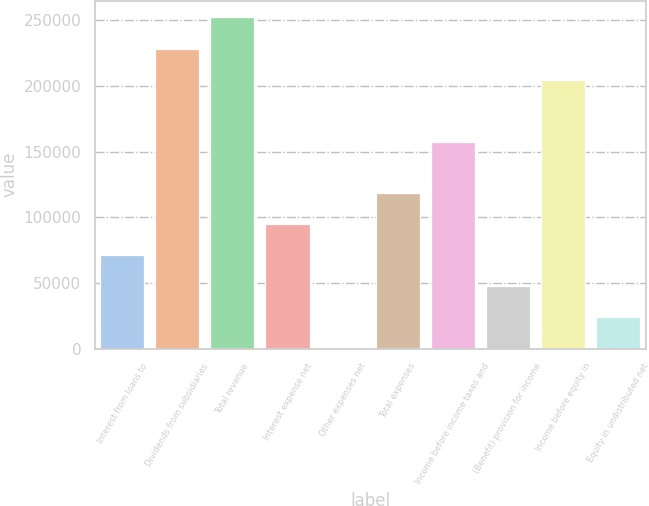Convert chart to OTSL. <chart><loc_0><loc_0><loc_500><loc_500><bar_chart><fcel>Interest from loans to<fcel>Dividends from subsidiaries<fcel>Total revenue<fcel>Interest expense net<fcel>Other expenses net<fcel>Total expenses<fcel>Income before income taxes and<fcel>(Benefit) provision for income<fcel>Income before equity in<fcel>Equity in undistributed net<nl><fcel>71391.7<fcel>228356<fcel>252057<fcel>95092.6<fcel>289<fcel>118794<fcel>157253<fcel>47690.8<fcel>204655<fcel>23989.9<nl></chart> 